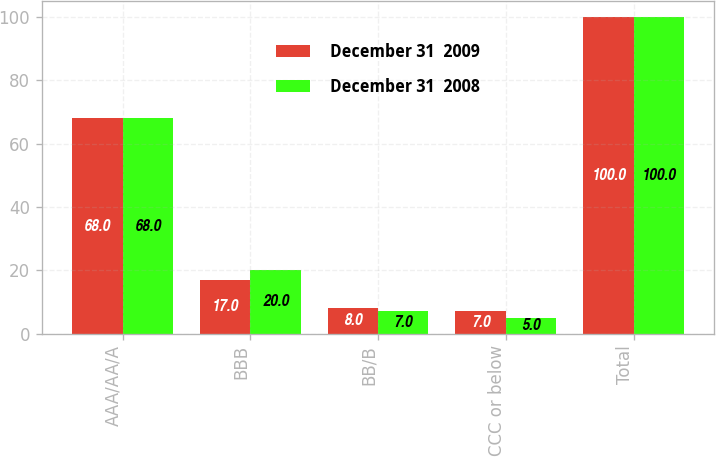<chart> <loc_0><loc_0><loc_500><loc_500><stacked_bar_chart><ecel><fcel>AAA/AA/A<fcel>BBB<fcel>BB/B<fcel>CCC or below<fcel>Total<nl><fcel>December 31  2009<fcel>68<fcel>17<fcel>8<fcel>7<fcel>100<nl><fcel>December 31  2008<fcel>68<fcel>20<fcel>7<fcel>5<fcel>100<nl></chart> 